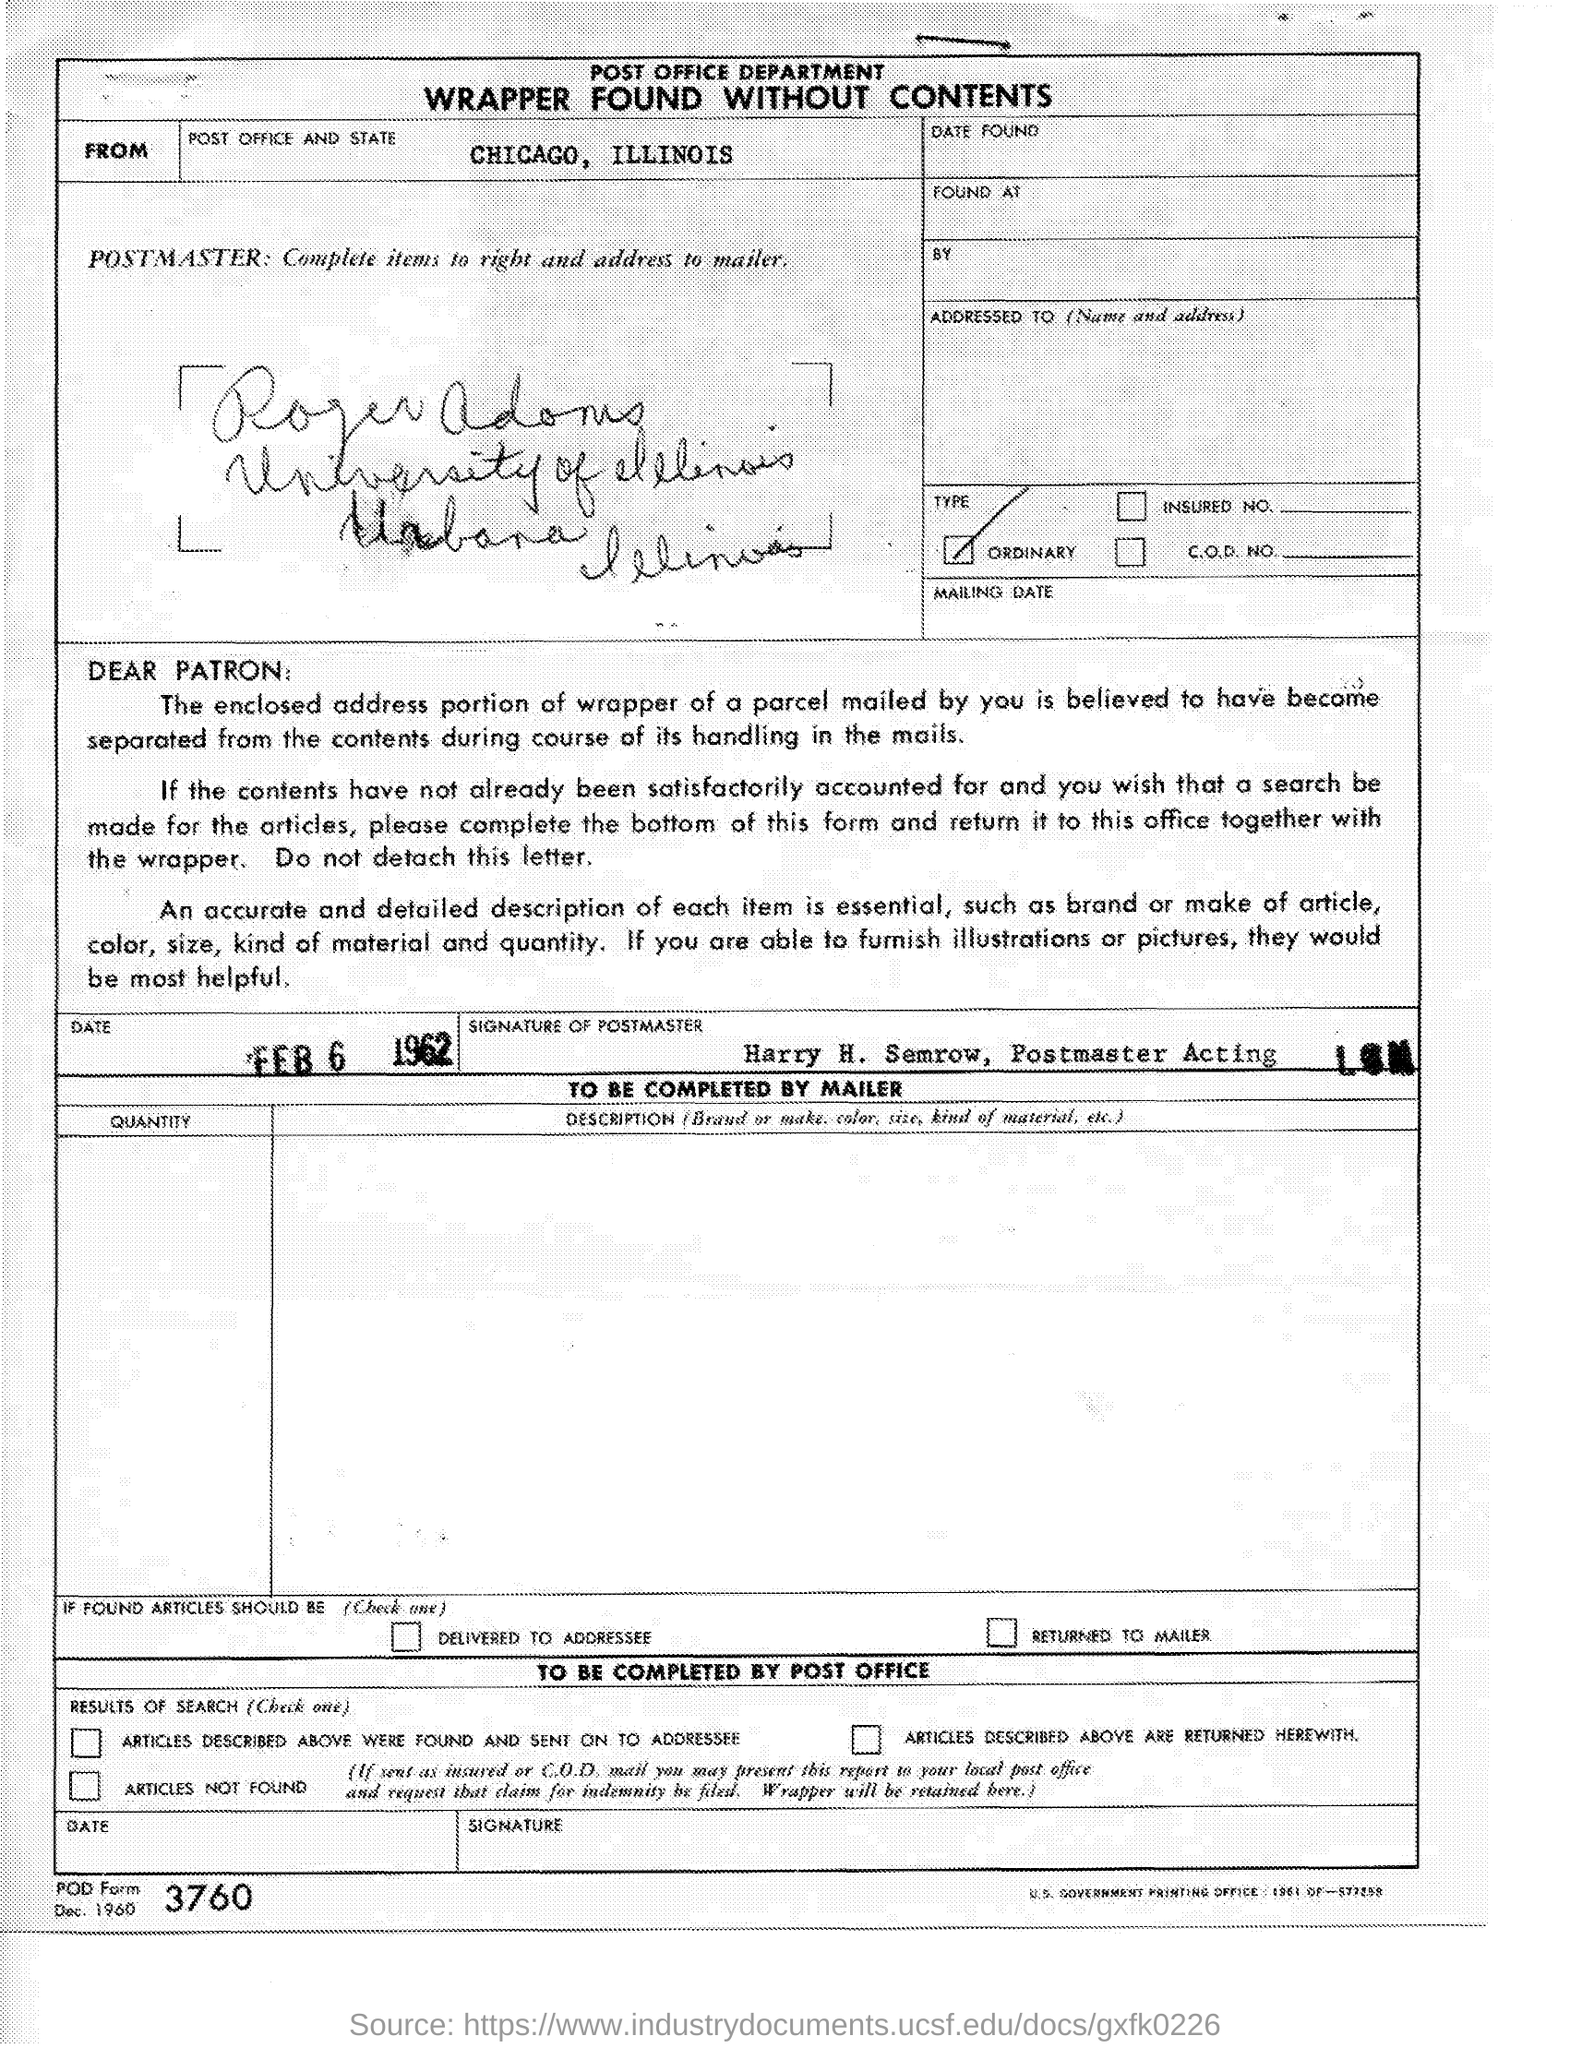List a handful of essential elements in this visual. The Post Office in Chicago, Illinois is a designated facility responsible for the processing, storage, and delivery of mail and other related services, including the acceptance and delivery of packages and other items weighing up to 70 pounds. The date being referred to is February 6, 1962. 